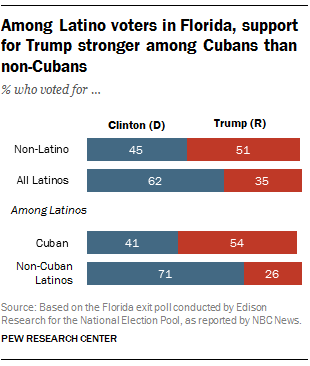Highlight a few significant elements in this photo. The Cuban percentage of voters who voted for Clinton (D) in the 2016 presidential election can be determined from the chart. The ratio of the number of Cuban alliances between Clinton (D) and Trump (R) is 2.73 times greater than that of Trump (R). 